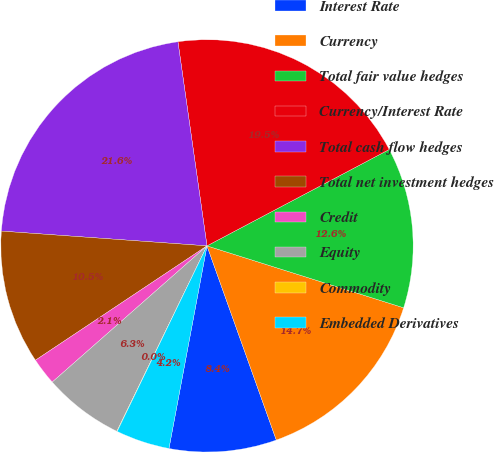<chart> <loc_0><loc_0><loc_500><loc_500><pie_chart><fcel>Interest Rate<fcel>Currency<fcel>Total fair value hedges<fcel>Currency/Interest Rate<fcel>Total cash flow hedges<fcel>Total net investment hedges<fcel>Credit<fcel>Equity<fcel>Commodity<fcel>Embedded Derivatives<nl><fcel>8.41%<fcel>14.69%<fcel>12.6%<fcel>19.51%<fcel>21.61%<fcel>10.5%<fcel>2.13%<fcel>6.31%<fcel>0.03%<fcel>4.22%<nl></chart> 